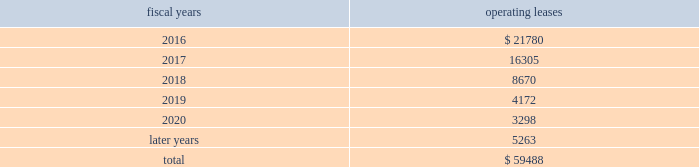Analog devices , inc .
Notes to consolidated financial statements 2014 ( continued ) the following is a schedule of future minimum rental payments required under long-term operating leases at october 31 , operating fiscal years leases .
12 .
Commitments and contingencies from time to time , in the ordinary course of the company 2019s business , various claims , charges and litigation are asserted or commenced against the company arising from , or related to , contractual matters , patents , trademarks , personal injury , environmental matters , product liability , insurance coverage and personnel and employment disputes .
As to such claims and litigation , the company can give no assurance that it will prevail .
The company does not believe that any current legal matters will have a material adverse effect on the company 2019s financial position , results of operations or cash flows .
13 .
Retirement plans the company and its subsidiaries have various savings and retirement plans covering substantially all employees .
The company maintains a defined contribution plan for the benefit of its eligible u.s .
Employees .
This plan provides for company contributions of up to 5% ( 5 % ) of each participant 2019s total eligible compensation .
In addition , the company contributes an amount equal to each participant 2019s pre-tax contribution , if any , up to a maximum of 3% ( 3 % ) of each participant 2019s total eligible compensation .
The total expense related to the defined contribution plan for u.s .
Employees was $ 26.3 million in fiscal 2015 , $ 24.1 million in fiscal 2014 and $ 23.1 million in fiscal 2013 .
The company also has various defined benefit pension and other retirement plans for certain non-u.s .
Employees that are consistent with local statutory requirements and practices .
The total expense related to the various defined benefit pension and other retirement plans for certain non-u.s .
Employees , excluding settlement charges related to the company's irish defined benefit plan , was $ 33.3 million in fiscal 2015 , $ 29.8 million in fiscal 2014 and $ 26.5 million in fiscal 2013 .
Non-u.s .
Plan disclosures during fiscal 2015 , the company converted the benefits provided to participants in the company 2019s irish defined benefits pension plan ( the db plan ) to benefits provided under the company 2019s irish defined contribution plan .
As a result , in fiscal 2015 the company recorded expenses of $ 223.7 million , including settlement charges , legal , accounting and other professional fees to settle the pension obligation .
The assets related to the db plan were liquidated and used to purchase annuities for retirees and distributed to active and deferred members' accounts in the company's irish defined contribution plan in connection with the plan conversion .
Accordingly , plan assets for the db plan were zero as of the end of fiscal 2015 .
The company 2019s funding policy for its foreign defined benefit pension plans is consistent with the local requirements of each country .
The plans 2019 assets consist primarily of u.s .
And non-u.s .
Equity securities , bonds , property and cash .
The benefit obligations and related assets under these plans have been measured at october 31 , 2015 and november 1 , 2014 .
Components of net periodic benefit cost net annual periodic pension cost of non-u.s .
Plans is presented in the following table: .
What portion of the future minimum rental payments is due in 2016? 
Computations: (21780 / 59488)
Answer: 0.36612. 